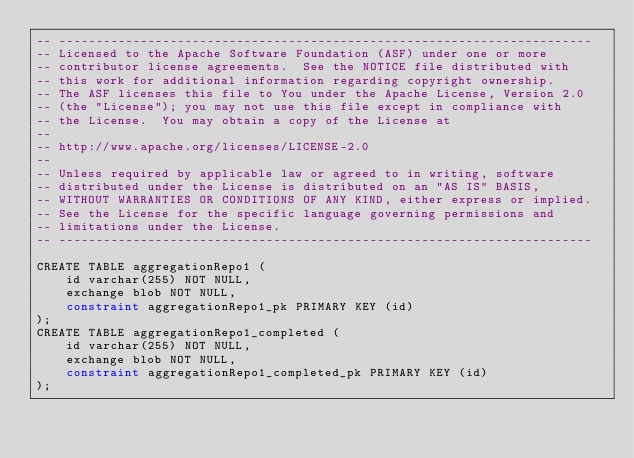Convert code to text. <code><loc_0><loc_0><loc_500><loc_500><_SQL_>-- ------------------------------------------------------------------------
-- Licensed to the Apache Software Foundation (ASF) under one or more
-- contributor license agreements.  See the NOTICE file distributed with
-- this work for additional information regarding copyright ownership.
-- The ASF licenses this file to You under the Apache License, Version 2.0
-- (the "License"); you may not use this file except in compliance with
-- the License.  You may obtain a copy of the License at
--
-- http://www.apache.org/licenses/LICENSE-2.0
--
-- Unless required by applicable law or agreed to in writing, software
-- distributed under the License is distributed on an "AS IS" BASIS,
-- WITHOUT WARRANTIES OR CONDITIONS OF ANY KIND, either express or implied.
-- See the License for the specific language governing permissions and
-- limitations under the License.
-- ------------------------------------------------------------------------

CREATE TABLE aggregationRepo1 (
    id varchar(255) NOT NULL,
    exchange blob NOT NULL,
    constraint aggregationRepo1_pk PRIMARY KEY (id)
);
CREATE TABLE aggregationRepo1_completed (
    id varchar(255) NOT NULL,
    exchange blob NOT NULL,
    constraint aggregationRepo1_completed_pk PRIMARY KEY (id)
);</code> 